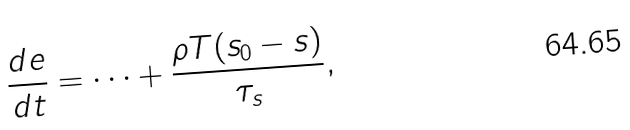<formula> <loc_0><loc_0><loc_500><loc_500>\frac { d e } { d t } = \dots + \frac { \rho T ( s _ { 0 } - s ) } { \tau _ { s } } ,</formula> 